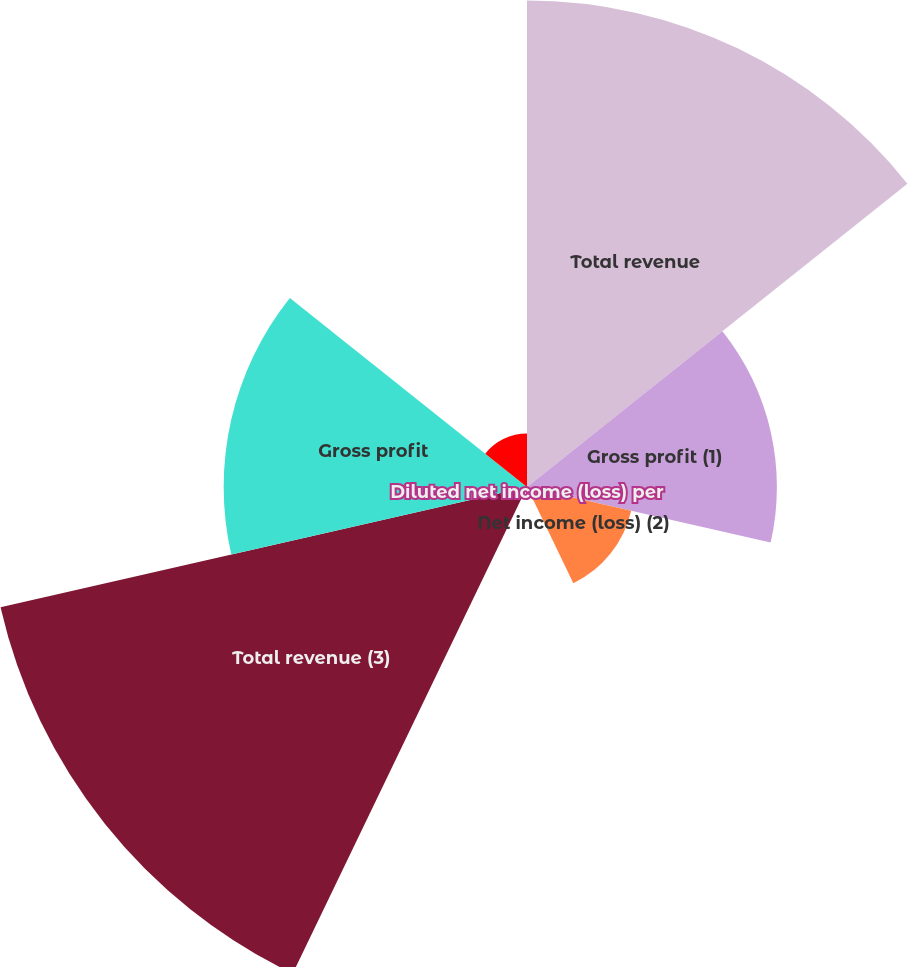<chart> <loc_0><loc_0><loc_500><loc_500><pie_chart><fcel>Total revenue<fcel>Gross profit (1)<fcel>Net income (loss) (2)<fcel>Diluted net income (loss) per<fcel>Total revenue (3)<fcel>Gross profit<fcel>Diluted net income(loss) per<nl><fcel>27.96%<fcel>14.36%<fcel>6.14%<fcel>0.0%<fcel>31.03%<fcel>17.43%<fcel>3.07%<nl></chart> 